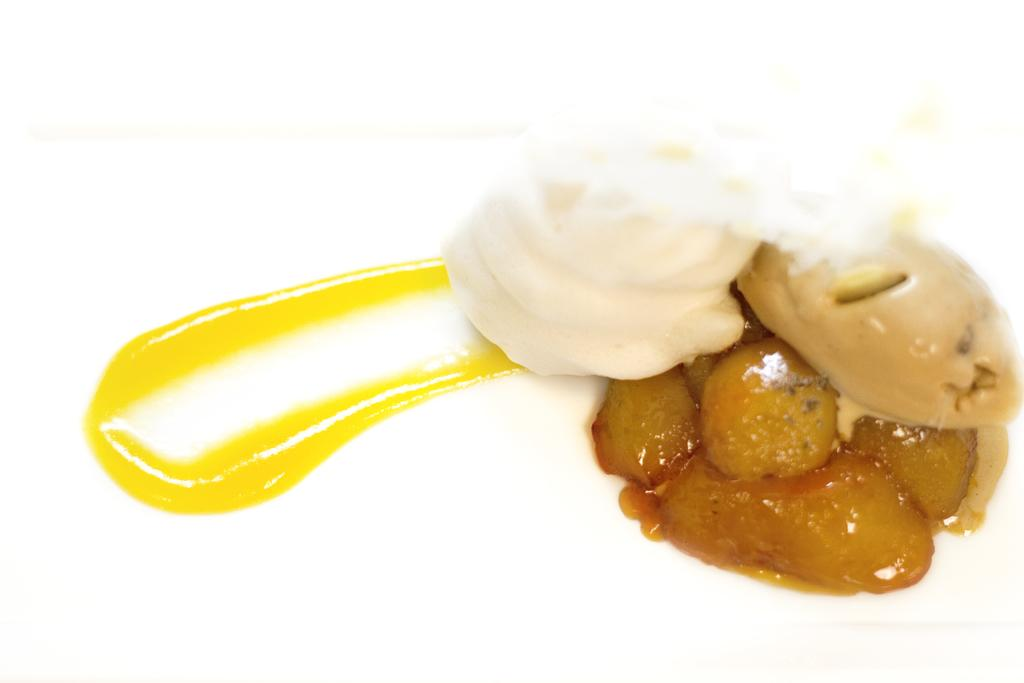What type of food is featured in the image? There is a dessert in the image. How many babies are crawling on the gold trail in the image? There are no babies or gold trails present in the image; it features a dessert. 